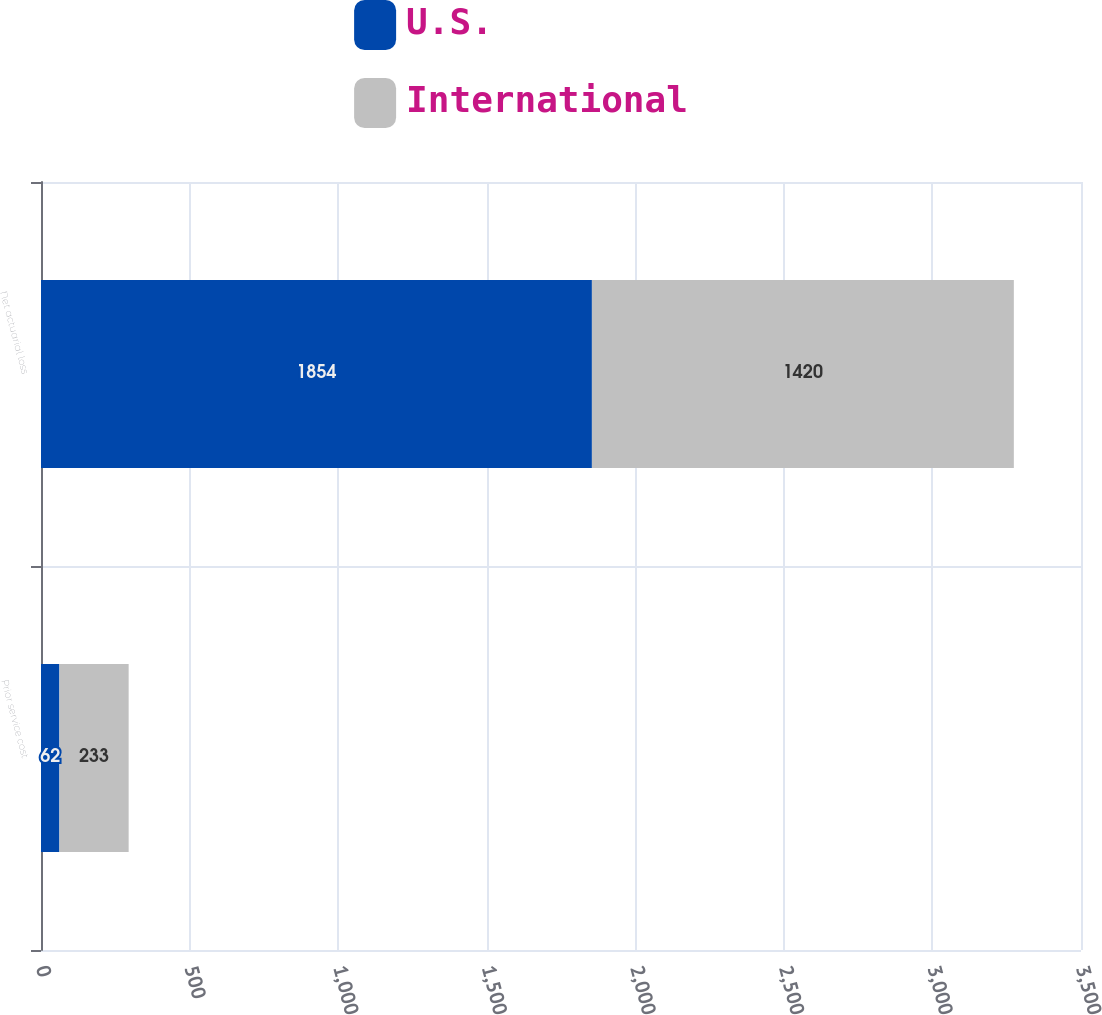<chart> <loc_0><loc_0><loc_500><loc_500><stacked_bar_chart><ecel><fcel>Prior service cost<fcel>Net actuarial loss<nl><fcel>U.S.<fcel>62<fcel>1854<nl><fcel>International<fcel>233<fcel>1420<nl></chart> 